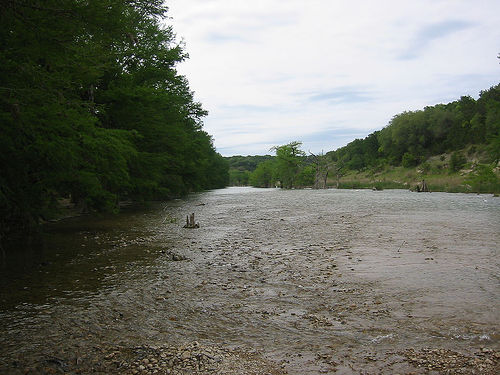<image>
Is there a stump above the river? No. The stump is not positioned above the river. The vertical arrangement shows a different relationship. 